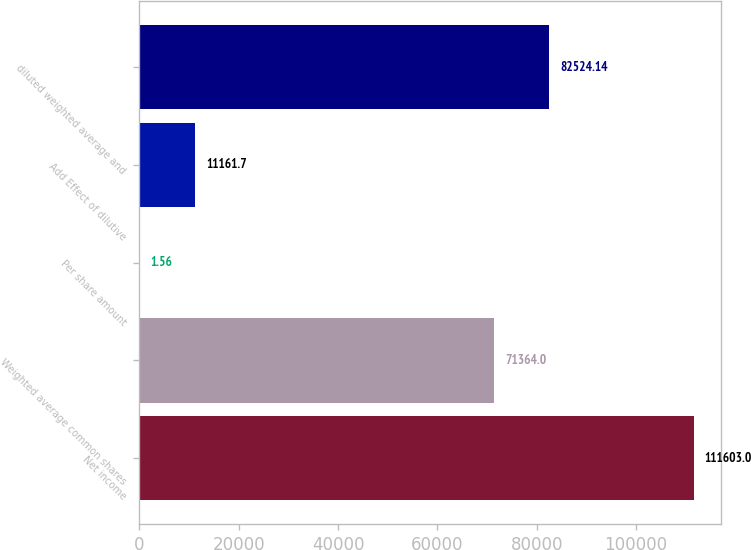<chart> <loc_0><loc_0><loc_500><loc_500><bar_chart><fcel>Net income<fcel>Weighted average common shares<fcel>Per share amount<fcel>Add Effect of dilutive<fcel>diluted weighted average and<nl><fcel>111603<fcel>71364<fcel>1.56<fcel>11161.7<fcel>82524.1<nl></chart> 